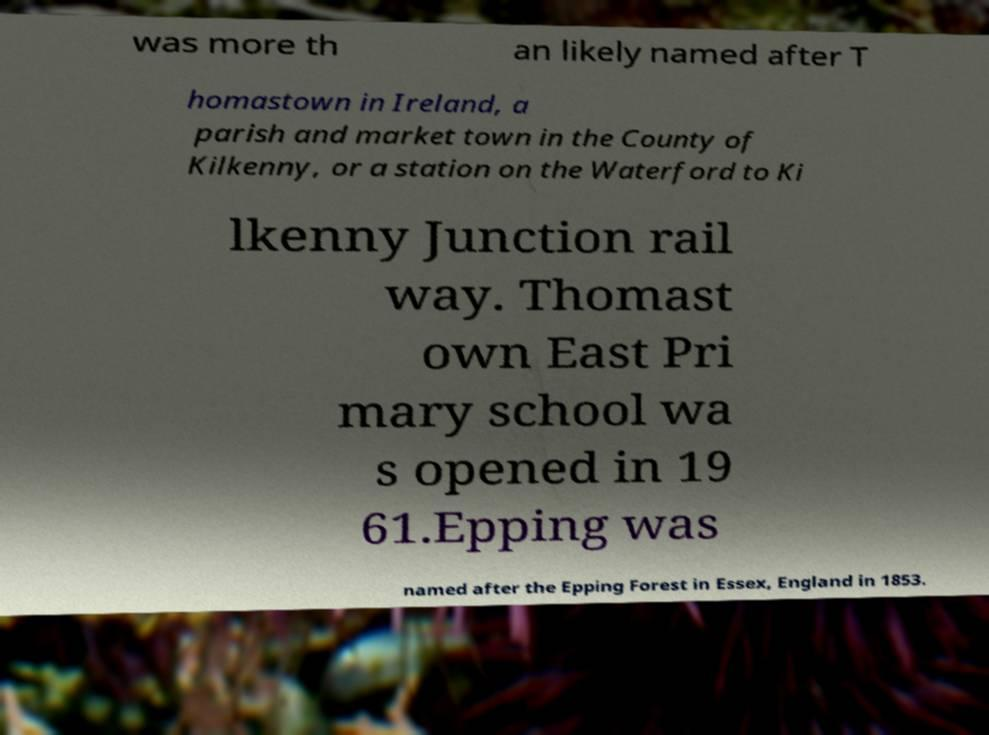Please read and relay the text visible in this image. What does it say? was more th an likely named after T homastown in Ireland, a parish and market town in the County of Kilkenny, or a station on the Waterford to Ki lkenny Junction rail way. Thomast own East Pri mary school wa s opened in 19 61.Epping was named after the Epping Forest in Essex, England in 1853. 